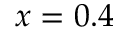Convert formula to latex. <formula><loc_0><loc_0><loc_500><loc_500>x = 0 . 4</formula> 